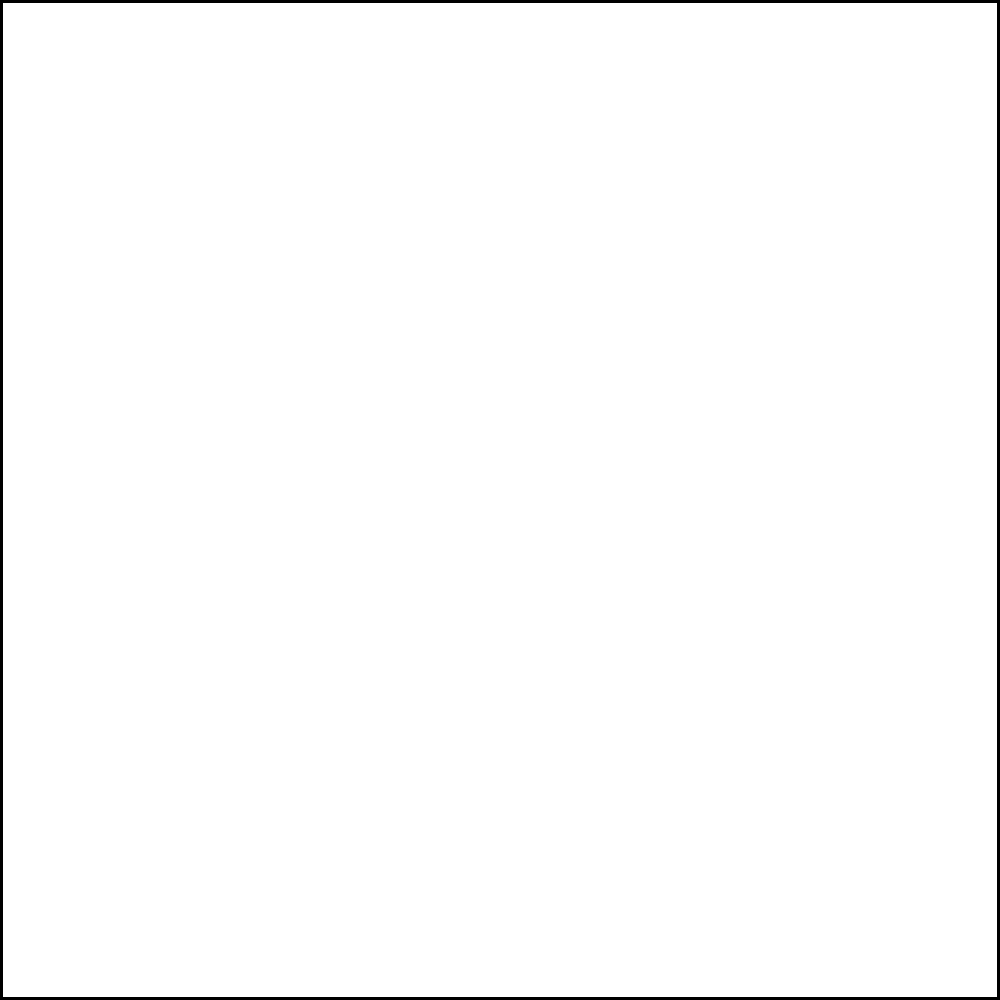In a TV ratings visualization, a square represents the maximum possible rating of 10, and an inscribed circle represents the actual rating of a popular international show. If the side length of the square is 4 units, what is the radius of the inscribed circle? Let's approach this step-by-step:

1) In a square with an inscribed circle, the diameter of the circle is equal to the side length of the square.

2) Given:
   - The side length of the square is 4 units.
   - Let the radius of the circle be $r$.

3) The diameter of the circle is equal to the side of the square:
   $$2r = 4$$

4) Solve for $r$:
   $$r = \frac{4}{2} = 2$$

5) Therefore, the radius of the inscribed circle is 2 units.

In the context of TV ratings, this means that if the square represents a maximum rating of 10, and the circle's radius is 2 units (half the square's side), the show's actual rating would be 5 out of 10.
Answer: 2 units 